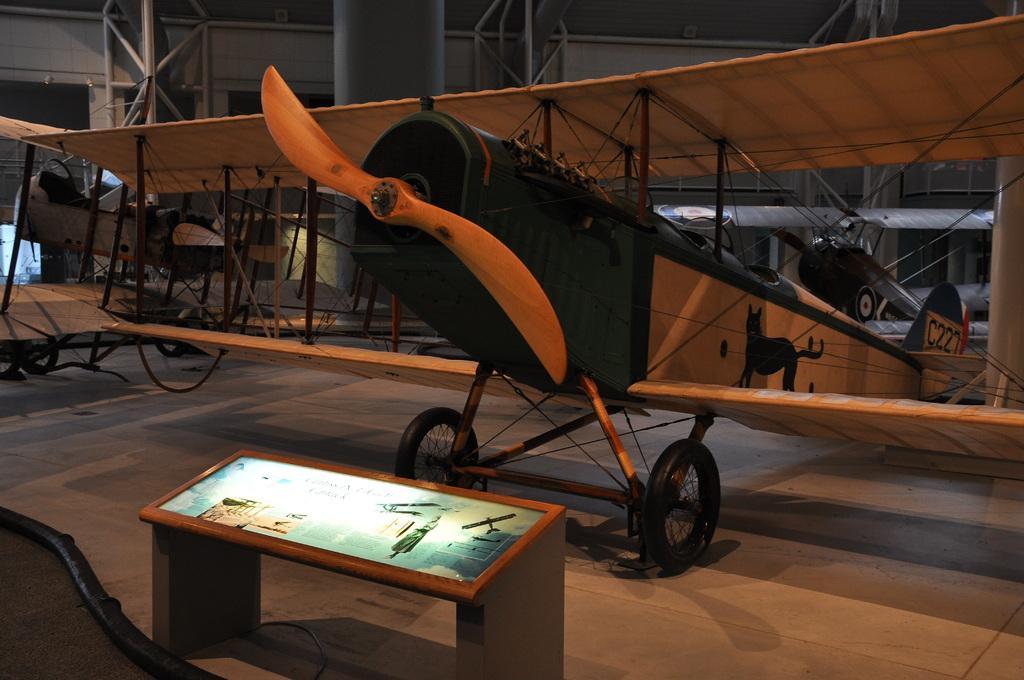Can you describe this image briefly? This is the picture of a airplane and there is a model frame in front of the airplane. 